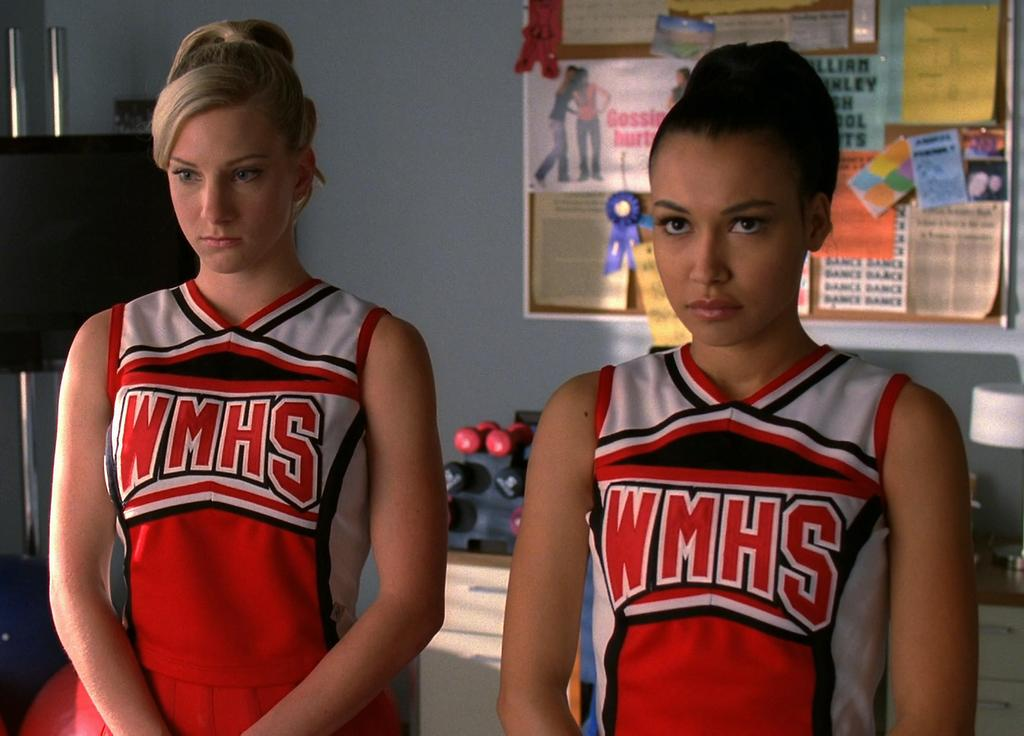Provide a one-sentence caption for the provided image. 2 women have cheerleading outfits that read WMHS. 